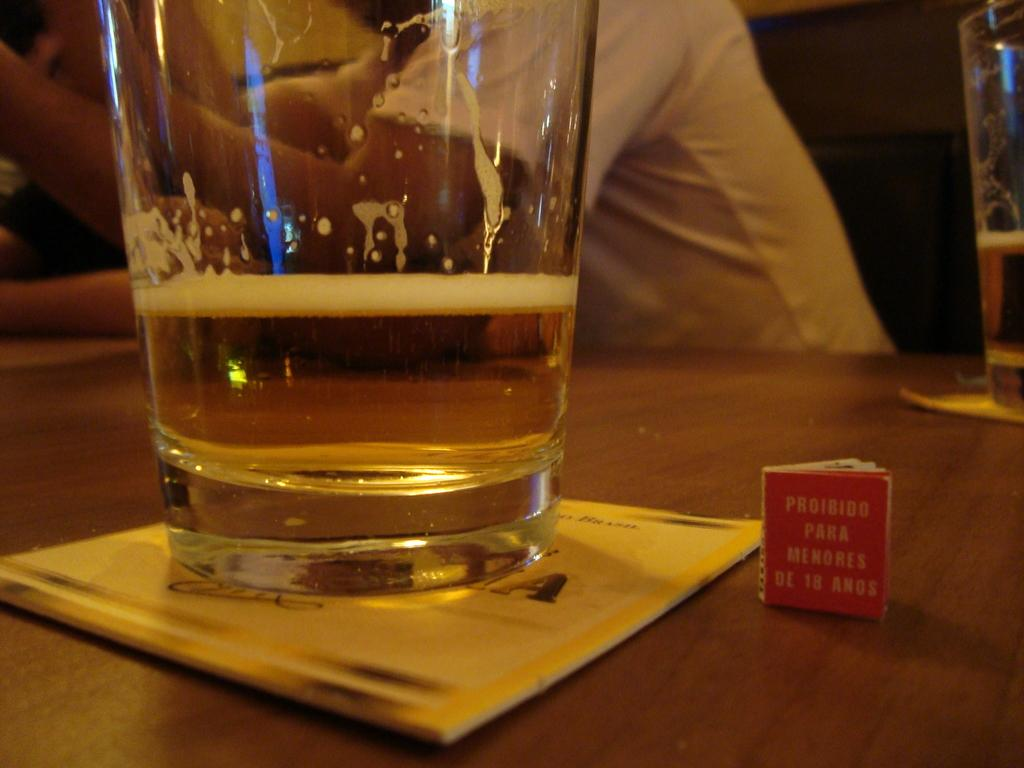<image>
Present a compact description of the photo's key features. a glass of alcohol next to a tiny book that is titled 'phoibido para menores de 18 anos' 